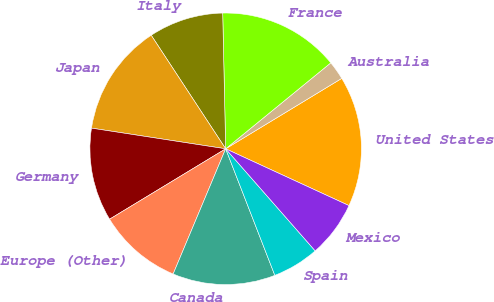<chart> <loc_0><loc_0><loc_500><loc_500><pie_chart><fcel>United States<fcel>Australia<fcel>France<fcel>Italy<fcel>Japan<fcel>Germany<fcel>Europe (Other)<fcel>Canada<fcel>Spain<fcel>Mexico<nl><fcel>15.55%<fcel>2.23%<fcel>14.44%<fcel>8.89%<fcel>13.33%<fcel>11.11%<fcel>10.0%<fcel>12.22%<fcel>5.56%<fcel>6.67%<nl></chart> 